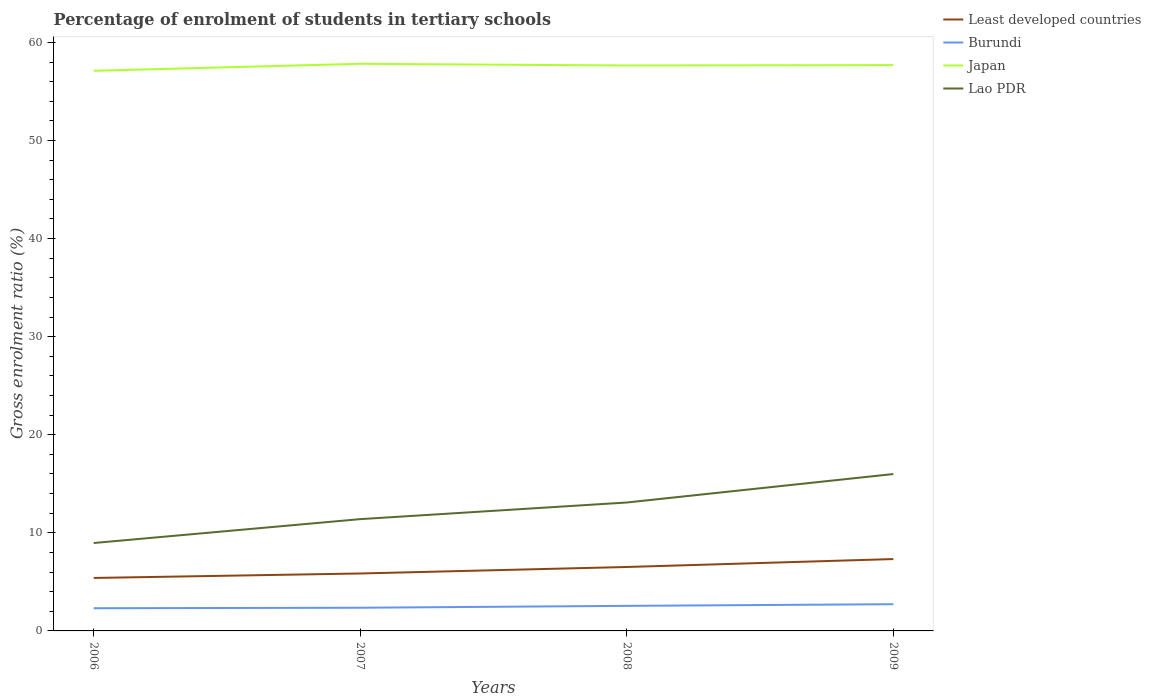Across all years, what is the maximum percentage of students enrolled in tertiary schools in Burundi?
Your answer should be very brief. 2.31. In which year was the percentage of students enrolled in tertiary schools in Lao PDR maximum?
Offer a very short reply. 2006. What is the total percentage of students enrolled in tertiary schools in Least developed countries in the graph?
Offer a terse response. -0.66. What is the difference between the highest and the second highest percentage of students enrolled in tertiary schools in Burundi?
Your answer should be very brief. 0.41. Is the percentage of students enrolled in tertiary schools in Japan strictly greater than the percentage of students enrolled in tertiary schools in Burundi over the years?
Your answer should be compact. No. What is the difference between two consecutive major ticks on the Y-axis?
Your response must be concise. 10. Are the values on the major ticks of Y-axis written in scientific E-notation?
Ensure brevity in your answer.  No. Does the graph contain any zero values?
Give a very brief answer. No. Does the graph contain grids?
Your answer should be compact. No. Where does the legend appear in the graph?
Give a very brief answer. Top right. How many legend labels are there?
Make the answer very short. 4. How are the legend labels stacked?
Give a very brief answer. Vertical. What is the title of the graph?
Your answer should be very brief. Percentage of enrolment of students in tertiary schools. Does "Sao Tome and Principe" appear as one of the legend labels in the graph?
Keep it short and to the point. No. What is the label or title of the X-axis?
Your answer should be compact. Years. What is the label or title of the Y-axis?
Offer a very short reply. Gross enrolment ratio (%). What is the Gross enrolment ratio (%) in Least developed countries in 2006?
Provide a succinct answer. 5.4. What is the Gross enrolment ratio (%) in Burundi in 2006?
Ensure brevity in your answer.  2.31. What is the Gross enrolment ratio (%) of Japan in 2006?
Offer a very short reply. 57.11. What is the Gross enrolment ratio (%) in Lao PDR in 2006?
Make the answer very short. 8.96. What is the Gross enrolment ratio (%) of Least developed countries in 2007?
Keep it short and to the point. 5.86. What is the Gross enrolment ratio (%) in Burundi in 2007?
Provide a short and direct response. 2.36. What is the Gross enrolment ratio (%) of Japan in 2007?
Your response must be concise. 57.82. What is the Gross enrolment ratio (%) of Lao PDR in 2007?
Offer a very short reply. 11.4. What is the Gross enrolment ratio (%) in Least developed countries in 2008?
Your answer should be compact. 6.52. What is the Gross enrolment ratio (%) of Burundi in 2008?
Your answer should be very brief. 2.56. What is the Gross enrolment ratio (%) in Japan in 2008?
Offer a very short reply. 57.64. What is the Gross enrolment ratio (%) of Lao PDR in 2008?
Ensure brevity in your answer.  13.09. What is the Gross enrolment ratio (%) of Least developed countries in 2009?
Provide a short and direct response. 7.33. What is the Gross enrolment ratio (%) of Burundi in 2009?
Offer a terse response. 2.72. What is the Gross enrolment ratio (%) in Japan in 2009?
Provide a succinct answer. 57.68. What is the Gross enrolment ratio (%) in Lao PDR in 2009?
Offer a terse response. 15.99. Across all years, what is the maximum Gross enrolment ratio (%) of Least developed countries?
Give a very brief answer. 7.33. Across all years, what is the maximum Gross enrolment ratio (%) in Burundi?
Keep it short and to the point. 2.72. Across all years, what is the maximum Gross enrolment ratio (%) in Japan?
Offer a very short reply. 57.82. Across all years, what is the maximum Gross enrolment ratio (%) in Lao PDR?
Give a very brief answer. 15.99. Across all years, what is the minimum Gross enrolment ratio (%) in Least developed countries?
Provide a succinct answer. 5.4. Across all years, what is the minimum Gross enrolment ratio (%) in Burundi?
Give a very brief answer. 2.31. Across all years, what is the minimum Gross enrolment ratio (%) of Japan?
Provide a succinct answer. 57.11. Across all years, what is the minimum Gross enrolment ratio (%) in Lao PDR?
Make the answer very short. 8.96. What is the total Gross enrolment ratio (%) of Least developed countries in the graph?
Your answer should be compact. 25.1. What is the total Gross enrolment ratio (%) of Burundi in the graph?
Your response must be concise. 9.95. What is the total Gross enrolment ratio (%) in Japan in the graph?
Give a very brief answer. 230.25. What is the total Gross enrolment ratio (%) of Lao PDR in the graph?
Keep it short and to the point. 49.45. What is the difference between the Gross enrolment ratio (%) of Least developed countries in 2006 and that in 2007?
Provide a short and direct response. -0.46. What is the difference between the Gross enrolment ratio (%) in Burundi in 2006 and that in 2007?
Your answer should be compact. -0.05. What is the difference between the Gross enrolment ratio (%) of Japan in 2006 and that in 2007?
Your response must be concise. -0.71. What is the difference between the Gross enrolment ratio (%) of Lao PDR in 2006 and that in 2007?
Your response must be concise. -2.43. What is the difference between the Gross enrolment ratio (%) in Least developed countries in 2006 and that in 2008?
Your response must be concise. -1.12. What is the difference between the Gross enrolment ratio (%) of Burundi in 2006 and that in 2008?
Keep it short and to the point. -0.24. What is the difference between the Gross enrolment ratio (%) in Japan in 2006 and that in 2008?
Provide a short and direct response. -0.54. What is the difference between the Gross enrolment ratio (%) in Lao PDR in 2006 and that in 2008?
Provide a succinct answer. -4.13. What is the difference between the Gross enrolment ratio (%) of Least developed countries in 2006 and that in 2009?
Offer a very short reply. -1.93. What is the difference between the Gross enrolment ratio (%) of Burundi in 2006 and that in 2009?
Offer a very short reply. -0.41. What is the difference between the Gross enrolment ratio (%) of Japan in 2006 and that in 2009?
Provide a succinct answer. -0.58. What is the difference between the Gross enrolment ratio (%) in Lao PDR in 2006 and that in 2009?
Make the answer very short. -7.03. What is the difference between the Gross enrolment ratio (%) of Least developed countries in 2007 and that in 2008?
Offer a very short reply. -0.66. What is the difference between the Gross enrolment ratio (%) of Burundi in 2007 and that in 2008?
Offer a terse response. -0.19. What is the difference between the Gross enrolment ratio (%) in Japan in 2007 and that in 2008?
Your answer should be very brief. 0.17. What is the difference between the Gross enrolment ratio (%) of Lao PDR in 2007 and that in 2008?
Your answer should be compact. -1.7. What is the difference between the Gross enrolment ratio (%) of Least developed countries in 2007 and that in 2009?
Your answer should be compact. -1.47. What is the difference between the Gross enrolment ratio (%) in Burundi in 2007 and that in 2009?
Ensure brevity in your answer.  -0.36. What is the difference between the Gross enrolment ratio (%) of Japan in 2007 and that in 2009?
Offer a terse response. 0.13. What is the difference between the Gross enrolment ratio (%) of Lao PDR in 2007 and that in 2009?
Make the answer very short. -4.6. What is the difference between the Gross enrolment ratio (%) of Least developed countries in 2008 and that in 2009?
Provide a succinct answer. -0.81. What is the difference between the Gross enrolment ratio (%) of Burundi in 2008 and that in 2009?
Provide a succinct answer. -0.17. What is the difference between the Gross enrolment ratio (%) in Japan in 2008 and that in 2009?
Offer a terse response. -0.04. What is the difference between the Gross enrolment ratio (%) of Lao PDR in 2008 and that in 2009?
Provide a short and direct response. -2.9. What is the difference between the Gross enrolment ratio (%) of Least developed countries in 2006 and the Gross enrolment ratio (%) of Burundi in 2007?
Keep it short and to the point. 3.04. What is the difference between the Gross enrolment ratio (%) of Least developed countries in 2006 and the Gross enrolment ratio (%) of Japan in 2007?
Your answer should be very brief. -52.42. What is the difference between the Gross enrolment ratio (%) of Least developed countries in 2006 and the Gross enrolment ratio (%) of Lao PDR in 2007?
Ensure brevity in your answer.  -6. What is the difference between the Gross enrolment ratio (%) in Burundi in 2006 and the Gross enrolment ratio (%) in Japan in 2007?
Give a very brief answer. -55.51. What is the difference between the Gross enrolment ratio (%) of Burundi in 2006 and the Gross enrolment ratio (%) of Lao PDR in 2007?
Provide a succinct answer. -9.08. What is the difference between the Gross enrolment ratio (%) in Japan in 2006 and the Gross enrolment ratio (%) in Lao PDR in 2007?
Keep it short and to the point. 45.71. What is the difference between the Gross enrolment ratio (%) of Least developed countries in 2006 and the Gross enrolment ratio (%) of Burundi in 2008?
Keep it short and to the point. 2.84. What is the difference between the Gross enrolment ratio (%) in Least developed countries in 2006 and the Gross enrolment ratio (%) in Japan in 2008?
Your answer should be compact. -52.24. What is the difference between the Gross enrolment ratio (%) in Least developed countries in 2006 and the Gross enrolment ratio (%) in Lao PDR in 2008?
Provide a succinct answer. -7.69. What is the difference between the Gross enrolment ratio (%) of Burundi in 2006 and the Gross enrolment ratio (%) of Japan in 2008?
Your answer should be compact. -55.33. What is the difference between the Gross enrolment ratio (%) in Burundi in 2006 and the Gross enrolment ratio (%) in Lao PDR in 2008?
Ensure brevity in your answer.  -10.78. What is the difference between the Gross enrolment ratio (%) in Japan in 2006 and the Gross enrolment ratio (%) in Lao PDR in 2008?
Offer a terse response. 44.01. What is the difference between the Gross enrolment ratio (%) of Least developed countries in 2006 and the Gross enrolment ratio (%) of Burundi in 2009?
Offer a very short reply. 2.68. What is the difference between the Gross enrolment ratio (%) of Least developed countries in 2006 and the Gross enrolment ratio (%) of Japan in 2009?
Give a very brief answer. -52.28. What is the difference between the Gross enrolment ratio (%) in Least developed countries in 2006 and the Gross enrolment ratio (%) in Lao PDR in 2009?
Your answer should be compact. -10.59. What is the difference between the Gross enrolment ratio (%) in Burundi in 2006 and the Gross enrolment ratio (%) in Japan in 2009?
Provide a succinct answer. -55.37. What is the difference between the Gross enrolment ratio (%) of Burundi in 2006 and the Gross enrolment ratio (%) of Lao PDR in 2009?
Keep it short and to the point. -13.68. What is the difference between the Gross enrolment ratio (%) of Japan in 2006 and the Gross enrolment ratio (%) of Lao PDR in 2009?
Make the answer very short. 41.11. What is the difference between the Gross enrolment ratio (%) of Least developed countries in 2007 and the Gross enrolment ratio (%) of Burundi in 2008?
Your response must be concise. 3.3. What is the difference between the Gross enrolment ratio (%) of Least developed countries in 2007 and the Gross enrolment ratio (%) of Japan in 2008?
Make the answer very short. -51.79. What is the difference between the Gross enrolment ratio (%) of Least developed countries in 2007 and the Gross enrolment ratio (%) of Lao PDR in 2008?
Offer a very short reply. -7.24. What is the difference between the Gross enrolment ratio (%) of Burundi in 2007 and the Gross enrolment ratio (%) of Japan in 2008?
Make the answer very short. -55.28. What is the difference between the Gross enrolment ratio (%) in Burundi in 2007 and the Gross enrolment ratio (%) in Lao PDR in 2008?
Provide a succinct answer. -10.73. What is the difference between the Gross enrolment ratio (%) of Japan in 2007 and the Gross enrolment ratio (%) of Lao PDR in 2008?
Your response must be concise. 44.73. What is the difference between the Gross enrolment ratio (%) of Least developed countries in 2007 and the Gross enrolment ratio (%) of Burundi in 2009?
Make the answer very short. 3.13. What is the difference between the Gross enrolment ratio (%) of Least developed countries in 2007 and the Gross enrolment ratio (%) of Japan in 2009?
Your answer should be compact. -51.83. What is the difference between the Gross enrolment ratio (%) of Least developed countries in 2007 and the Gross enrolment ratio (%) of Lao PDR in 2009?
Give a very brief answer. -10.14. What is the difference between the Gross enrolment ratio (%) in Burundi in 2007 and the Gross enrolment ratio (%) in Japan in 2009?
Provide a short and direct response. -55.32. What is the difference between the Gross enrolment ratio (%) in Burundi in 2007 and the Gross enrolment ratio (%) in Lao PDR in 2009?
Your response must be concise. -13.63. What is the difference between the Gross enrolment ratio (%) in Japan in 2007 and the Gross enrolment ratio (%) in Lao PDR in 2009?
Offer a terse response. 41.82. What is the difference between the Gross enrolment ratio (%) of Least developed countries in 2008 and the Gross enrolment ratio (%) of Burundi in 2009?
Give a very brief answer. 3.79. What is the difference between the Gross enrolment ratio (%) in Least developed countries in 2008 and the Gross enrolment ratio (%) in Japan in 2009?
Provide a short and direct response. -51.17. What is the difference between the Gross enrolment ratio (%) in Least developed countries in 2008 and the Gross enrolment ratio (%) in Lao PDR in 2009?
Offer a terse response. -9.48. What is the difference between the Gross enrolment ratio (%) of Burundi in 2008 and the Gross enrolment ratio (%) of Japan in 2009?
Keep it short and to the point. -55.13. What is the difference between the Gross enrolment ratio (%) of Burundi in 2008 and the Gross enrolment ratio (%) of Lao PDR in 2009?
Give a very brief answer. -13.44. What is the difference between the Gross enrolment ratio (%) of Japan in 2008 and the Gross enrolment ratio (%) of Lao PDR in 2009?
Keep it short and to the point. 41.65. What is the average Gross enrolment ratio (%) of Least developed countries per year?
Offer a terse response. 6.27. What is the average Gross enrolment ratio (%) of Burundi per year?
Provide a succinct answer. 2.49. What is the average Gross enrolment ratio (%) of Japan per year?
Offer a very short reply. 57.56. What is the average Gross enrolment ratio (%) in Lao PDR per year?
Offer a very short reply. 12.36. In the year 2006, what is the difference between the Gross enrolment ratio (%) of Least developed countries and Gross enrolment ratio (%) of Burundi?
Your answer should be very brief. 3.09. In the year 2006, what is the difference between the Gross enrolment ratio (%) in Least developed countries and Gross enrolment ratio (%) in Japan?
Your answer should be very brief. -51.71. In the year 2006, what is the difference between the Gross enrolment ratio (%) of Least developed countries and Gross enrolment ratio (%) of Lao PDR?
Keep it short and to the point. -3.56. In the year 2006, what is the difference between the Gross enrolment ratio (%) in Burundi and Gross enrolment ratio (%) in Japan?
Provide a short and direct response. -54.79. In the year 2006, what is the difference between the Gross enrolment ratio (%) of Burundi and Gross enrolment ratio (%) of Lao PDR?
Keep it short and to the point. -6.65. In the year 2006, what is the difference between the Gross enrolment ratio (%) of Japan and Gross enrolment ratio (%) of Lao PDR?
Your answer should be compact. 48.14. In the year 2007, what is the difference between the Gross enrolment ratio (%) of Least developed countries and Gross enrolment ratio (%) of Burundi?
Offer a very short reply. 3.49. In the year 2007, what is the difference between the Gross enrolment ratio (%) in Least developed countries and Gross enrolment ratio (%) in Japan?
Your answer should be compact. -51.96. In the year 2007, what is the difference between the Gross enrolment ratio (%) of Least developed countries and Gross enrolment ratio (%) of Lao PDR?
Keep it short and to the point. -5.54. In the year 2007, what is the difference between the Gross enrolment ratio (%) in Burundi and Gross enrolment ratio (%) in Japan?
Your answer should be compact. -55.45. In the year 2007, what is the difference between the Gross enrolment ratio (%) in Burundi and Gross enrolment ratio (%) in Lao PDR?
Make the answer very short. -9.03. In the year 2007, what is the difference between the Gross enrolment ratio (%) of Japan and Gross enrolment ratio (%) of Lao PDR?
Your answer should be compact. 46.42. In the year 2008, what is the difference between the Gross enrolment ratio (%) in Least developed countries and Gross enrolment ratio (%) in Burundi?
Provide a succinct answer. 3.96. In the year 2008, what is the difference between the Gross enrolment ratio (%) of Least developed countries and Gross enrolment ratio (%) of Japan?
Your answer should be compact. -51.13. In the year 2008, what is the difference between the Gross enrolment ratio (%) in Least developed countries and Gross enrolment ratio (%) in Lao PDR?
Provide a short and direct response. -6.58. In the year 2008, what is the difference between the Gross enrolment ratio (%) in Burundi and Gross enrolment ratio (%) in Japan?
Keep it short and to the point. -55.09. In the year 2008, what is the difference between the Gross enrolment ratio (%) in Burundi and Gross enrolment ratio (%) in Lao PDR?
Offer a terse response. -10.54. In the year 2008, what is the difference between the Gross enrolment ratio (%) of Japan and Gross enrolment ratio (%) of Lao PDR?
Offer a terse response. 44.55. In the year 2009, what is the difference between the Gross enrolment ratio (%) in Least developed countries and Gross enrolment ratio (%) in Burundi?
Give a very brief answer. 4.6. In the year 2009, what is the difference between the Gross enrolment ratio (%) in Least developed countries and Gross enrolment ratio (%) in Japan?
Offer a terse response. -50.36. In the year 2009, what is the difference between the Gross enrolment ratio (%) in Least developed countries and Gross enrolment ratio (%) in Lao PDR?
Your answer should be compact. -8.67. In the year 2009, what is the difference between the Gross enrolment ratio (%) of Burundi and Gross enrolment ratio (%) of Japan?
Ensure brevity in your answer.  -54.96. In the year 2009, what is the difference between the Gross enrolment ratio (%) of Burundi and Gross enrolment ratio (%) of Lao PDR?
Your answer should be compact. -13.27. In the year 2009, what is the difference between the Gross enrolment ratio (%) of Japan and Gross enrolment ratio (%) of Lao PDR?
Your answer should be compact. 41.69. What is the ratio of the Gross enrolment ratio (%) in Least developed countries in 2006 to that in 2007?
Your answer should be very brief. 0.92. What is the ratio of the Gross enrolment ratio (%) in Burundi in 2006 to that in 2007?
Your response must be concise. 0.98. What is the ratio of the Gross enrolment ratio (%) in Lao PDR in 2006 to that in 2007?
Keep it short and to the point. 0.79. What is the ratio of the Gross enrolment ratio (%) of Least developed countries in 2006 to that in 2008?
Provide a succinct answer. 0.83. What is the ratio of the Gross enrolment ratio (%) of Burundi in 2006 to that in 2008?
Your response must be concise. 0.9. What is the ratio of the Gross enrolment ratio (%) in Lao PDR in 2006 to that in 2008?
Offer a terse response. 0.68. What is the ratio of the Gross enrolment ratio (%) of Least developed countries in 2006 to that in 2009?
Provide a succinct answer. 0.74. What is the ratio of the Gross enrolment ratio (%) in Burundi in 2006 to that in 2009?
Offer a very short reply. 0.85. What is the ratio of the Gross enrolment ratio (%) in Lao PDR in 2006 to that in 2009?
Ensure brevity in your answer.  0.56. What is the ratio of the Gross enrolment ratio (%) in Least developed countries in 2007 to that in 2008?
Provide a succinct answer. 0.9. What is the ratio of the Gross enrolment ratio (%) in Burundi in 2007 to that in 2008?
Ensure brevity in your answer.  0.92. What is the ratio of the Gross enrolment ratio (%) of Japan in 2007 to that in 2008?
Your response must be concise. 1. What is the ratio of the Gross enrolment ratio (%) in Lao PDR in 2007 to that in 2008?
Provide a short and direct response. 0.87. What is the ratio of the Gross enrolment ratio (%) in Least developed countries in 2007 to that in 2009?
Your response must be concise. 0.8. What is the ratio of the Gross enrolment ratio (%) of Burundi in 2007 to that in 2009?
Keep it short and to the point. 0.87. What is the ratio of the Gross enrolment ratio (%) in Japan in 2007 to that in 2009?
Make the answer very short. 1. What is the ratio of the Gross enrolment ratio (%) in Lao PDR in 2007 to that in 2009?
Offer a very short reply. 0.71. What is the ratio of the Gross enrolment ratio (%) in Least developed countries in 2008 to that in 2009?
Ensure brevity in your answer.  0.89. What is the ratio of the Gross enrolment ratio (%) of Burundi in 2008 to that in 2009?
Ensure brevity in your answer.  0.94. What is the ratio of the Gross enrolment ratio (%) of Lao PDR in 2008 to that in 2009?
Make the answer very short. 0.82. What is the difference between the highest and the second highest Gross enrolment ratio (%) of Least developed countries?
Your answer should be compact. 0.81. What is the difference between the highest and the second highest Gross enrolment ratio (%) of Burundi?
Offer a very short reply. 0.17. What is the difference between the highest and the second highest Gross enrolment ratio (%) of Japan?
Offer a terse response. 0.13. What is the difference between the highest and the second highest Gross enrolment ratio (%) in Lao PDR?
Your response must be concise. 2.9. What is the difference between the highest and the lowest Gross enrolment ratio (%) of Least developed countries?
Provide a short and direct response. 1.93. What is the difference between the highest and the lowest Gross enrolment ratio (%) in Burundi?
Keep it short and to the point. 0.41. What is the difference between the highest and the lowest Gross enrolment ratio (%) of Japan?
Offer a very short reply. 0.71. What is the difference between the highest and the lowest Gross enrolment ratio (%) of Lao PDR?
Give a very brief answer. 7.03. 